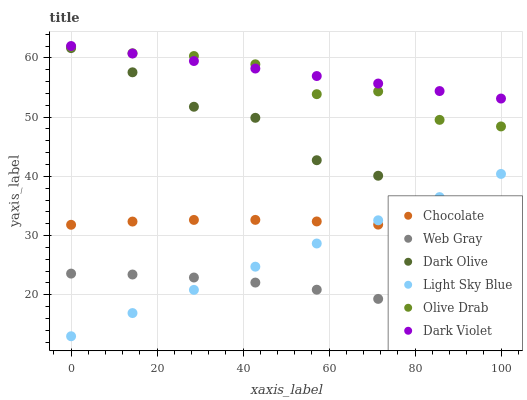Does Web Gray have the minimum area under the curve?
Answer yes or no. Yes. Does Dark Violet have the maximum area under the curve?
Answer yes or no. Yes. Does Dark Olive have the minimum area under the curve?
Answer yes or no. No. Does Dark Olive have the maximum area under the curve?
Answer yes or no. No. Is Light Sky Blue the smoothest?
Answer yes or no. Yes. Is Olive Drab the roughest?
Answer yes or no. Yes. Is Dark Olive the smoothest?
Answer yes or no. No. Is Dark Olive the roughest?
Answer yes or no. No. Does Light Sky Blue have the lowest value?
Answer yes or no. Yes. Does Dark Olive have the lowest value?
Answer yes or no. No. Does Dark Violet have the highest value?
Answer yes or no. Yes. Does Dark Olive have the highest value?
Answer yes or no. No. Is Web Gray less than Dark Violet?
Answer yes or no. Yes. Is Olive Drab greater than Dark Olive?
Answer yes or no. Yes. Does Light Sky Blue intersect Web Gray?
Answer yes or no. Yes. Is Light Sky Blue less than Web Gray?
Answer yes or no. No. Is Light Sky Blue greater than Web Gray?
Answer yes or no. No. Does Web Gray intersect Dark Violet?
Answer yes or no. No. 